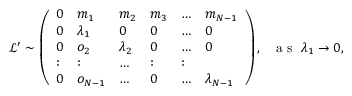Convert formula to latex. <formula><loc_0><loc_0><loc_500><loc_500>\begin{array} { r } { \, \mathcal { L } ^ { \prime } \sim \left ( \begin{array} { l l l l l l } { 0 } & { m _ { 1 } } & { m _ { 2 } } & { m _ { 3 } } & { \dots } & { m _ { N - 1 } } \\ { 0 } & { \lambda _ { 1 } } & { 0 } & { 0 } & { \dots } & { 0 } \\ { 0 } & { o _ { 2 } } & { \lambda _ { 2 } } & { 0 } & { \dots } & { 0 } \\ { \colon } & { \colon } & { \dots } & { \colon } & { \colon } \\ { 0 } & { o _ { N - 1 } } & { \dots } & { 0 } & { \dots } & { \lambda _ { N - 1 } } \end{array} \right ) , a s \lambda _ { 1 } \rightarrow 0 , } \end{array}</formula> 